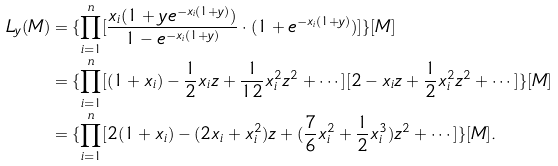Convert formula to latex. <formula><loc_0><loc_0><loc_500><loc_500>L _ { y } ( M ) & = \{ \prod _ { i = 1 } ^ { n } [ \frac { x _ { i } ( 1 + y e ^ { - x _ { i } ( 1 + y ) } ) } { 1 - e ^ { - x _ { i } ( 1 + y ) } } \cdot ( 1 + e ^ { - x _ { i } ( 1 + y ) } ) ] \} [ M ] \\ & = \{ \prod _ { i = 1 } ^ { n } [ ( 1 + x _ { i } ) - \frac { 1 } { 2 } x _ { i } z + \frac { 1 } { 1 2 } x _ { i } ^ { 2 } z ^ { 2 } + \cdots ] [ 2 - x _ { i } z + \frac { 1 } { 2 } x _ { i } ^ { 2 } z ^ { 2 } + \cdots ] \} [ M ] \\ & = \{ \prod _ { i = 1 } ^ { n } [ 2 ( 1 + x _ { i } ) - ( 2 x _ { i } + x _ { i } ^ { 2 } ) z + ( \frac { 7 } { 6 } x _ { i } ^ { 2 } + \frac { 1 } { 2 } x _ { i } ^ { 3 } ) z ^ { 2 } + \cdots ] \} [ M ] .</formula> 